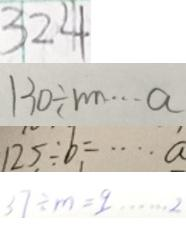<formula> <loc_0><loc_0><loc_500><loc_500>3 2 4 
 1 3 0 \div m \cdots a 
 1 2 5 \div b = \cdots \dot { a } 
 3 7 \div m = 9 \cdots 2</formula> 